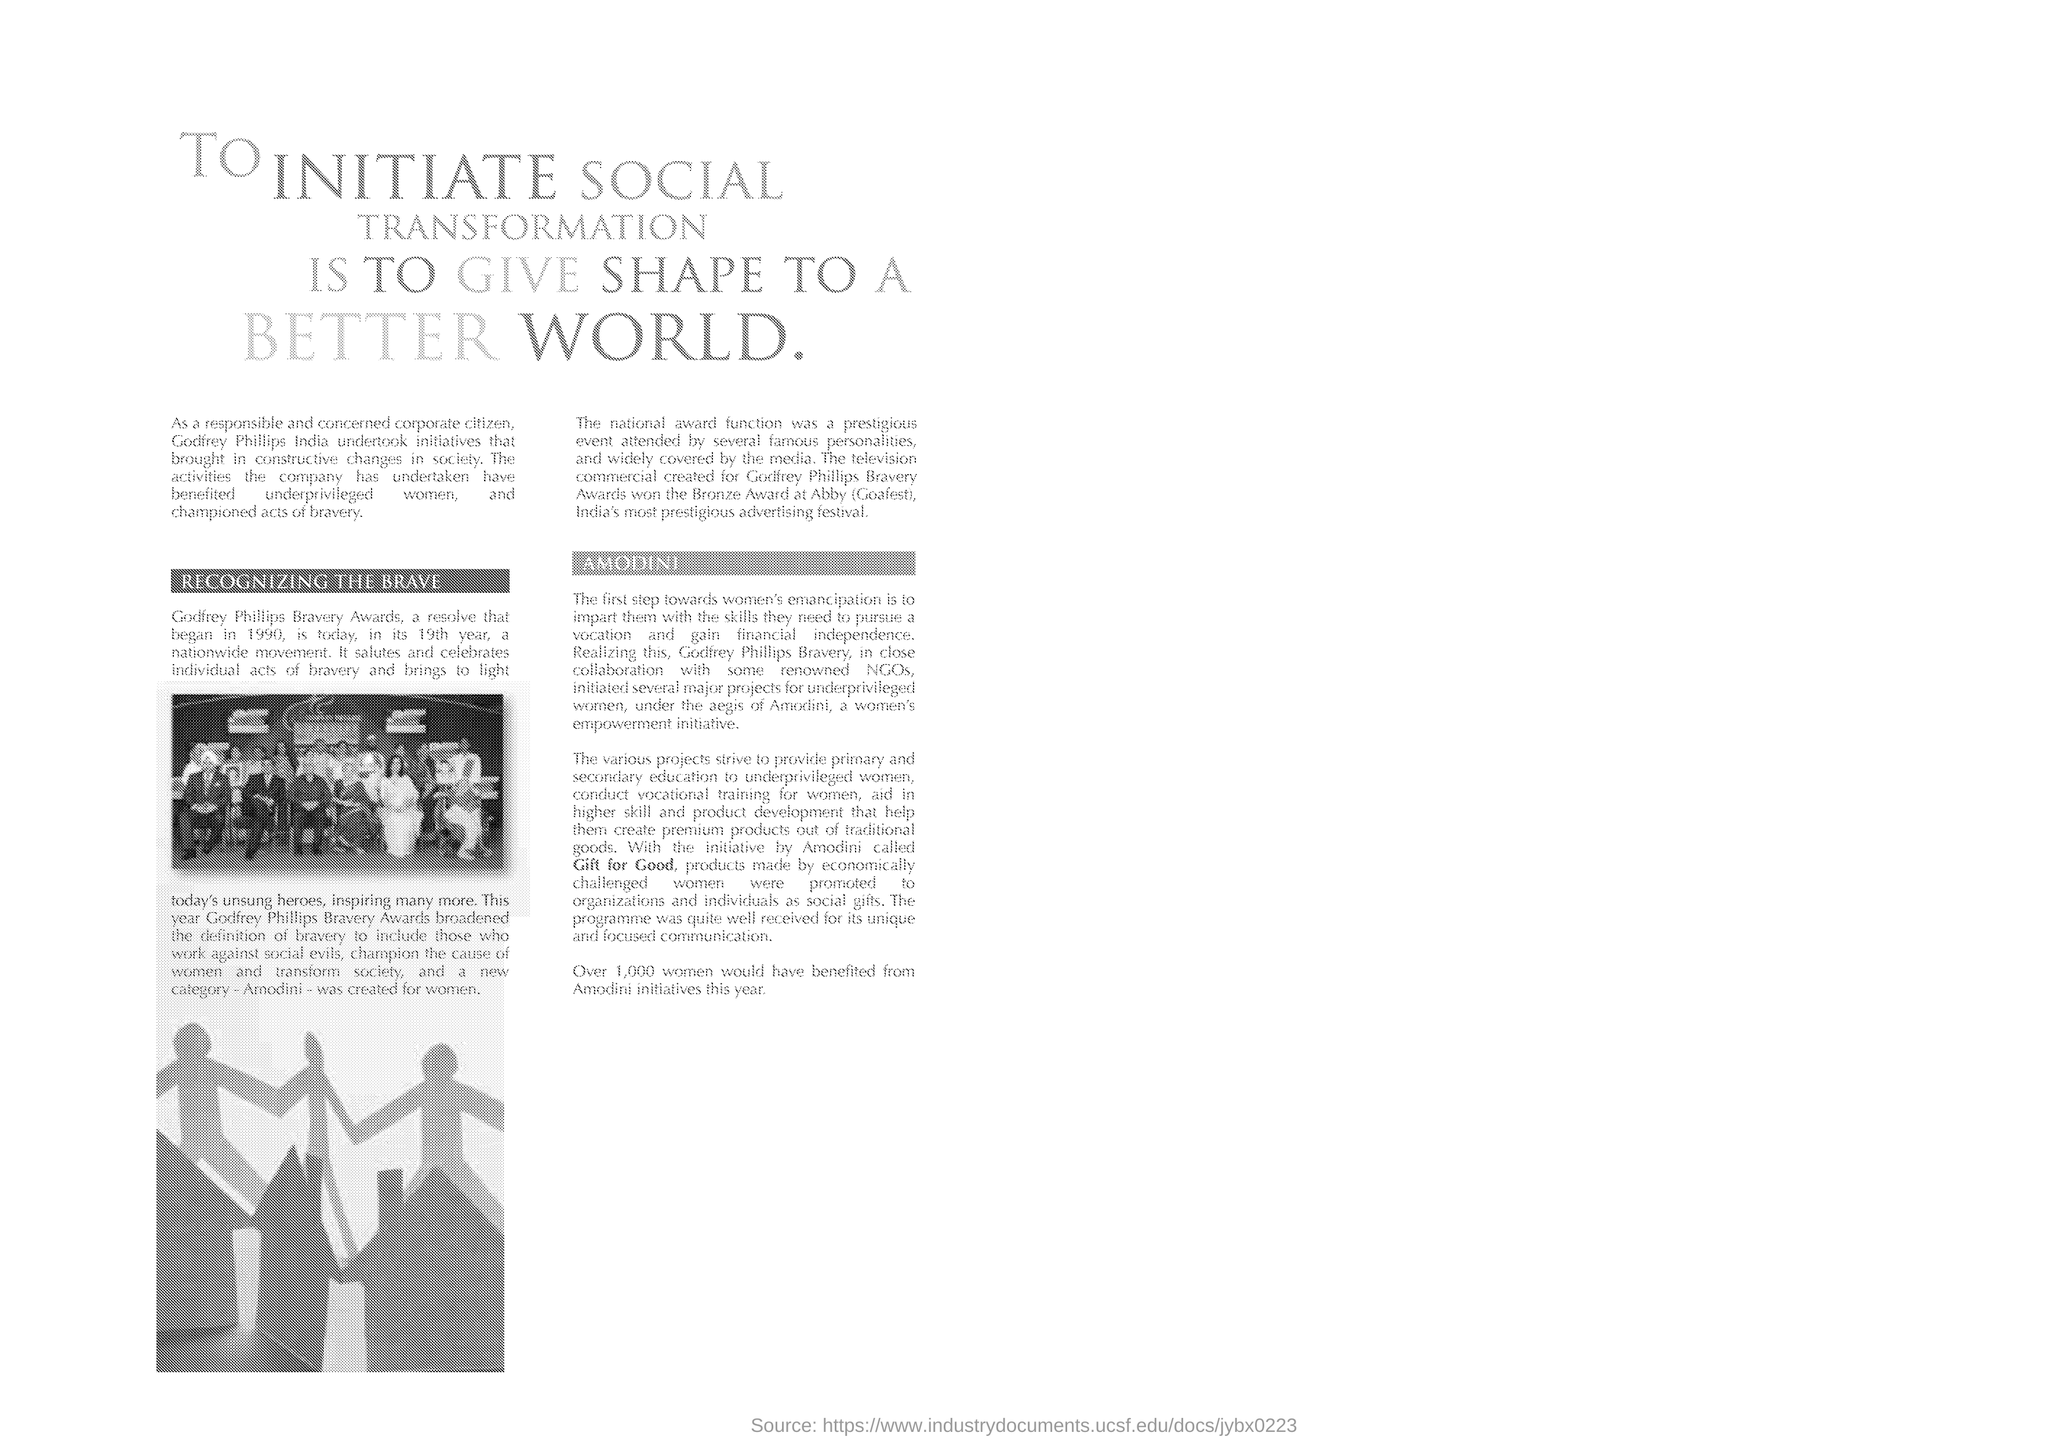Indicate a few pertinent items in this graphic. Amodini initiated the "Gift for Good" campaign, which promotes products made by economically challenged women. Last year, Amodini initiatives helped over 1,000 women. Godfrey Phillips India undertook initiatives that brought in constructive changes in society. The first subheading in the document is 'RECOGNIZING THE BRAVE.' The new category created for women in the Godfrey Phillips Bravery Awards is called "Amodini. 